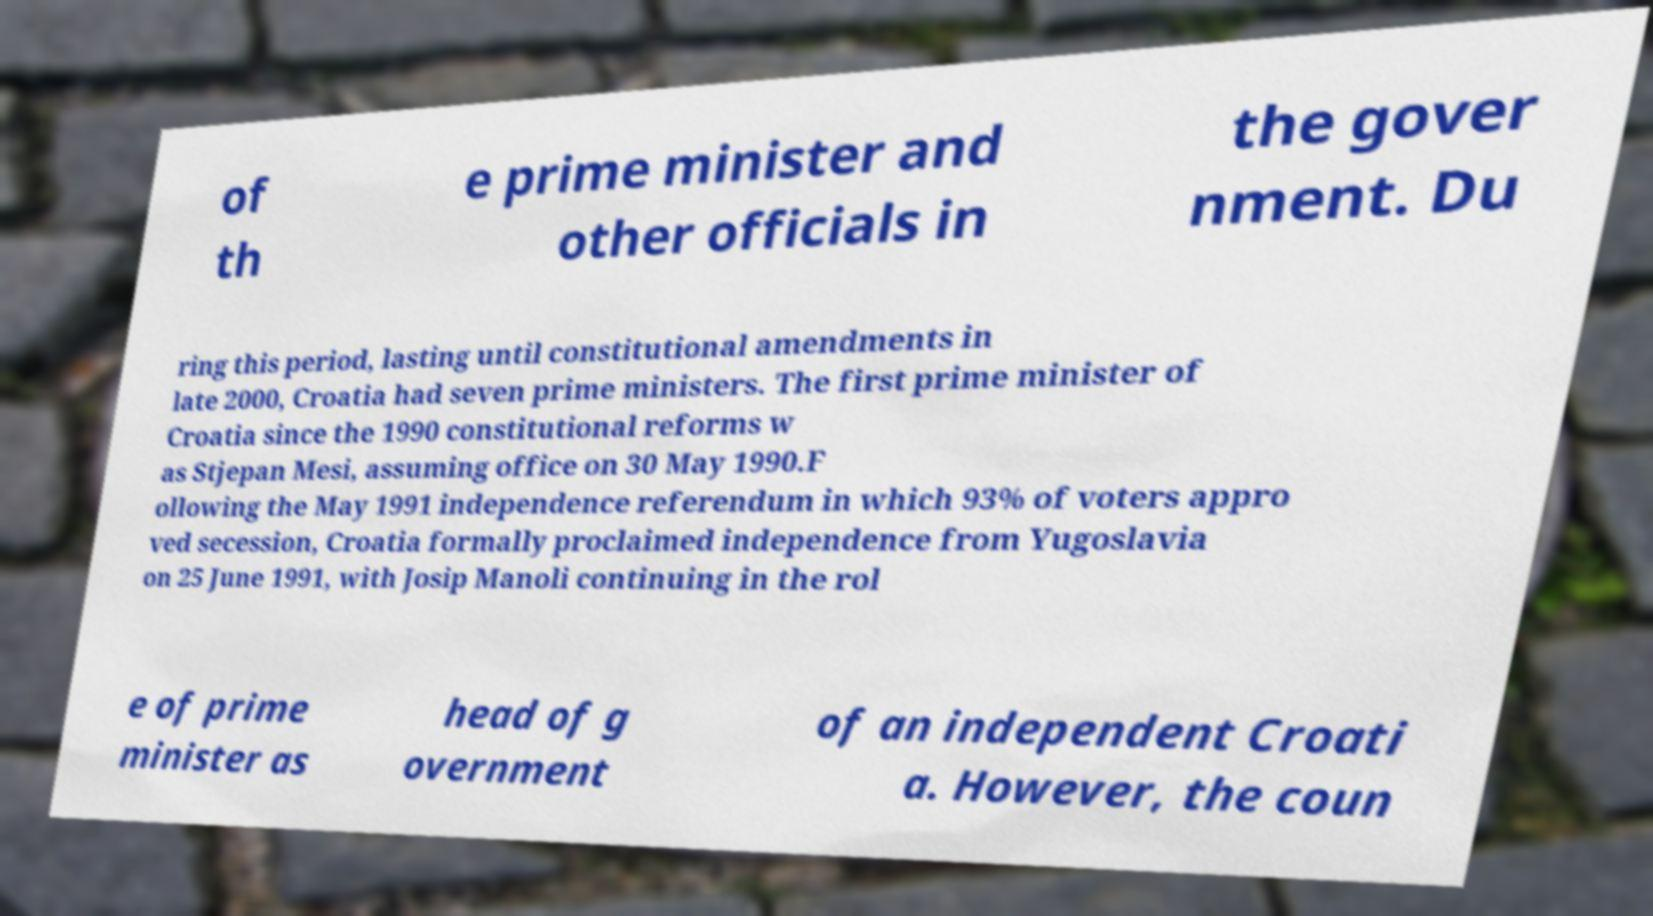Please identify and transcribe the text found in this image. of th e prime minister and other officials in the gover nment. Du ring this period, lasting until constitutional amendments in late 2000, Croatia had seven prime ministers. The first prime minister of Croatia since the 1990 constitutional reforms w as Stjepan Mesi, assuming office on 30 May 1990.F ollowing the May 1991 independence referendum in which 93% of voters appro ved secession, Croatia formally proclaimed independence from Yugoslavia on 25 June 1991, with Josip Manoli continuing in the rol e of prime minister as head of g overnment of an independent Croati a. However, the coun 